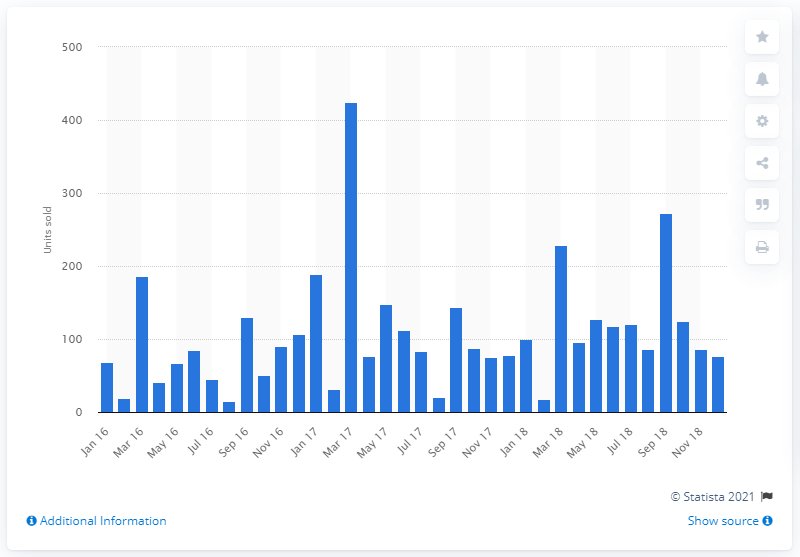Outline some significant characteristics in this image. In 2018, Aston Martin had a total of 21 dealerships operating in the United Kingdom. In March 2017, a total of 425 Aston Martin cars were sold. 